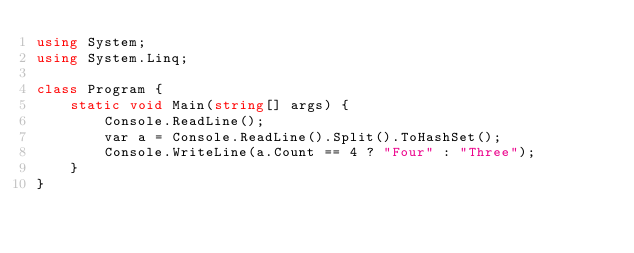<code> <loc_0><loc_0><loc_500><loc_500><_C#_>using System;
using System.Linq;

class Program {
    static void Main(string[] args) {
        Console.ReadLine();
        var a = Console.ReadLine().Split().ToHashSet();
        Console.WriteLine(a.Count == 4 ? "Four" : "Three");
    }
}</code> 